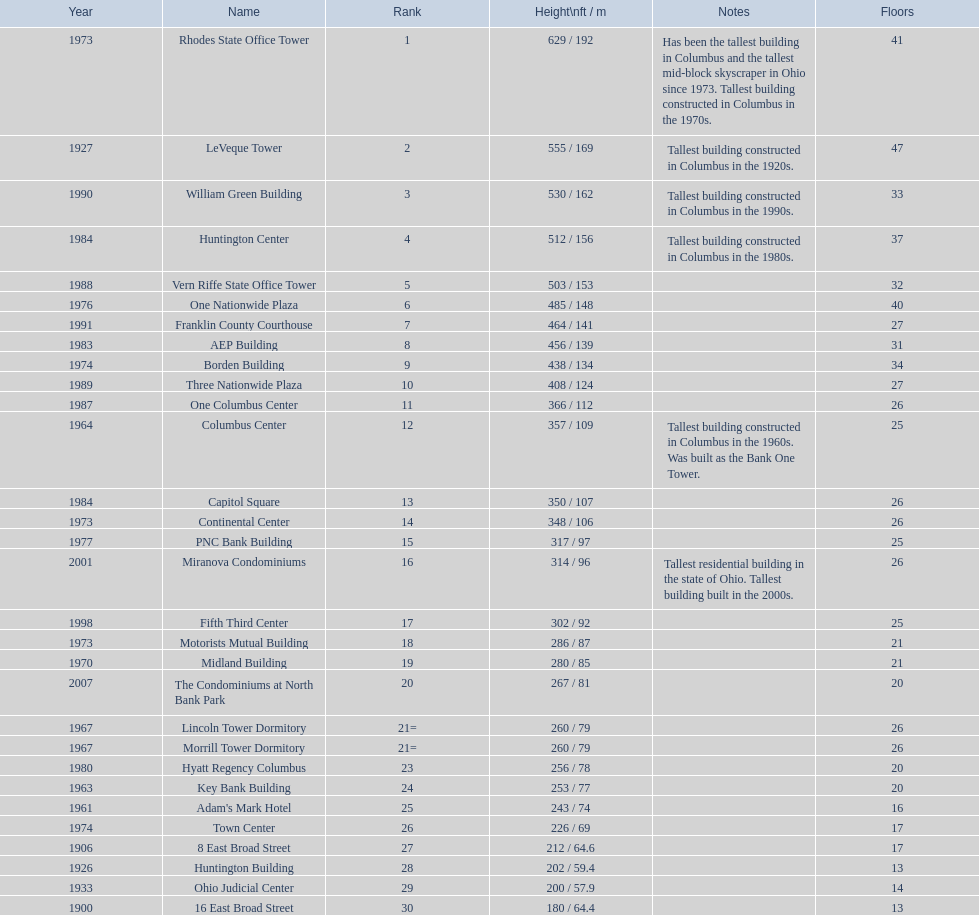How tall is the aep building? 456 / 139. How tall is the one columbus center? 366 / 112. Of these two buildings, which is taller? AEP Building. 